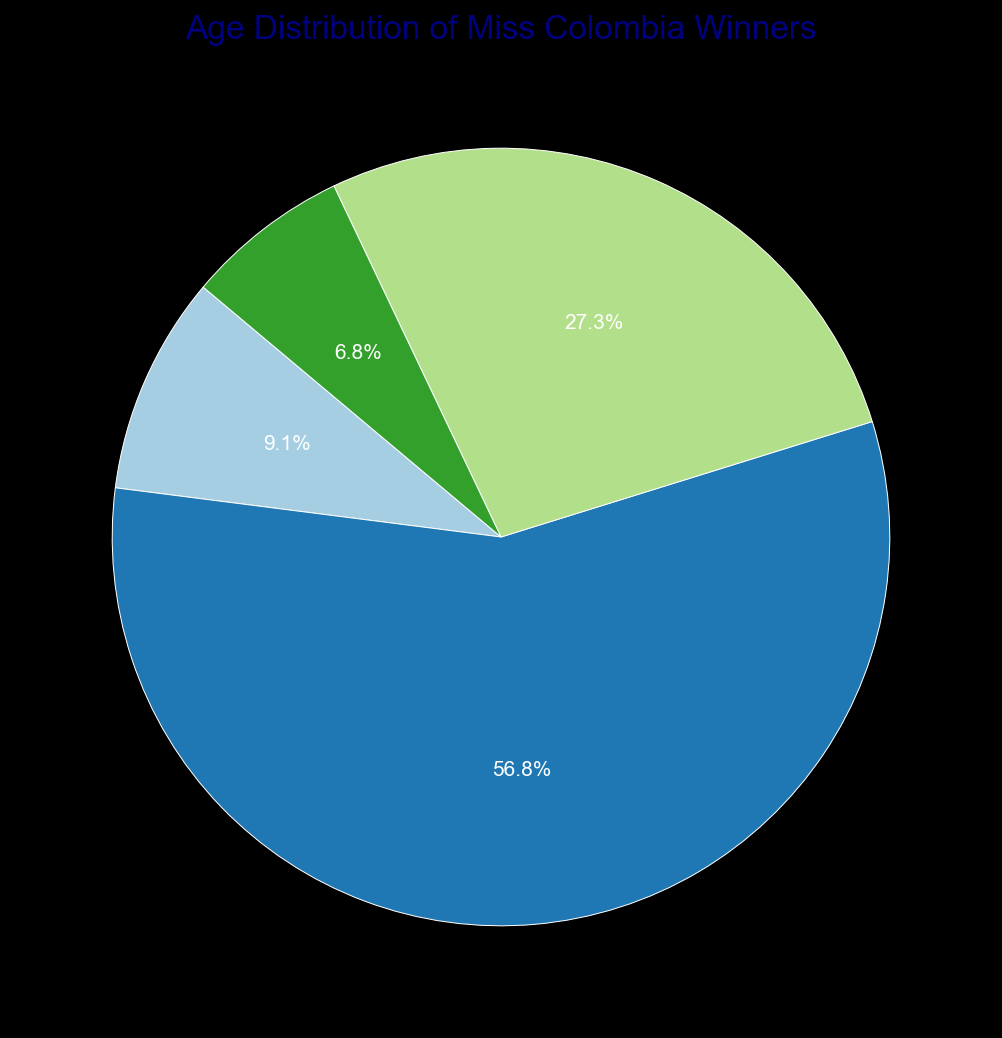Which age range has the highest count of Miss Colombia winners? By looking at the pie chart, we can see the section with the largest portion, represented by '20-22'. This is the age range with the highest count.
Answer: 20-22 Which age range has the lowest count of Miss Colombia winners? The pie chart shows the smallest portion, represented by '26-28'. This is the age range with the lowest count.
Answer: 26-28 How does the count of winners in the '20-22' age range compare to those in the '23-25' age range? The pie chart indicates that the '20-22' age range has a larger portion than the '23-25' age range. Specifically, there are 25 winners in '20-22' compared to 12 in '23-25'.
Answer: More What colors represent the age ranges '20-22' and '17-19'? The pie chart uses different colors for each range. According to the chart, '20-22' is represented by a specific color (e.g., blue) and '17-19' by another color (e.g., red).
Answer: Blue for '20-22' and red for '17-19' (exact colors can vary based on specific plot) Which age range is closest in size to the '23-25' group? By comparing the visual sizes of the portions in the pie chart, the group '17-19' seems closest in size to the '23-25' group with a small difference in the segment size.
Answer: 17-19 What is the total number of Miss Colombia winners represented in the pie chart? The total is calculated by summing all values in the data: 4 (17-19) + 25 (20-22) + 12 (23-25) + 3 (26-28) = 44.
Answer: 44 What is the percentage of winners who are aged between 17-22? First, sum the counts for the '17-19' and '20-22' groups, which is 4 + 25 = 29. Then, calculate the percentage by (29 / 44) * 100 = 65.9%.
Answer: 65.9% What is the difference in the number of winners between the most common and least common age ranges? The most common age range '20-22' has 25 winners, and the least common '26-28' has 3 winners. The difference is 25 - 3 = 22.
Answer: 22 